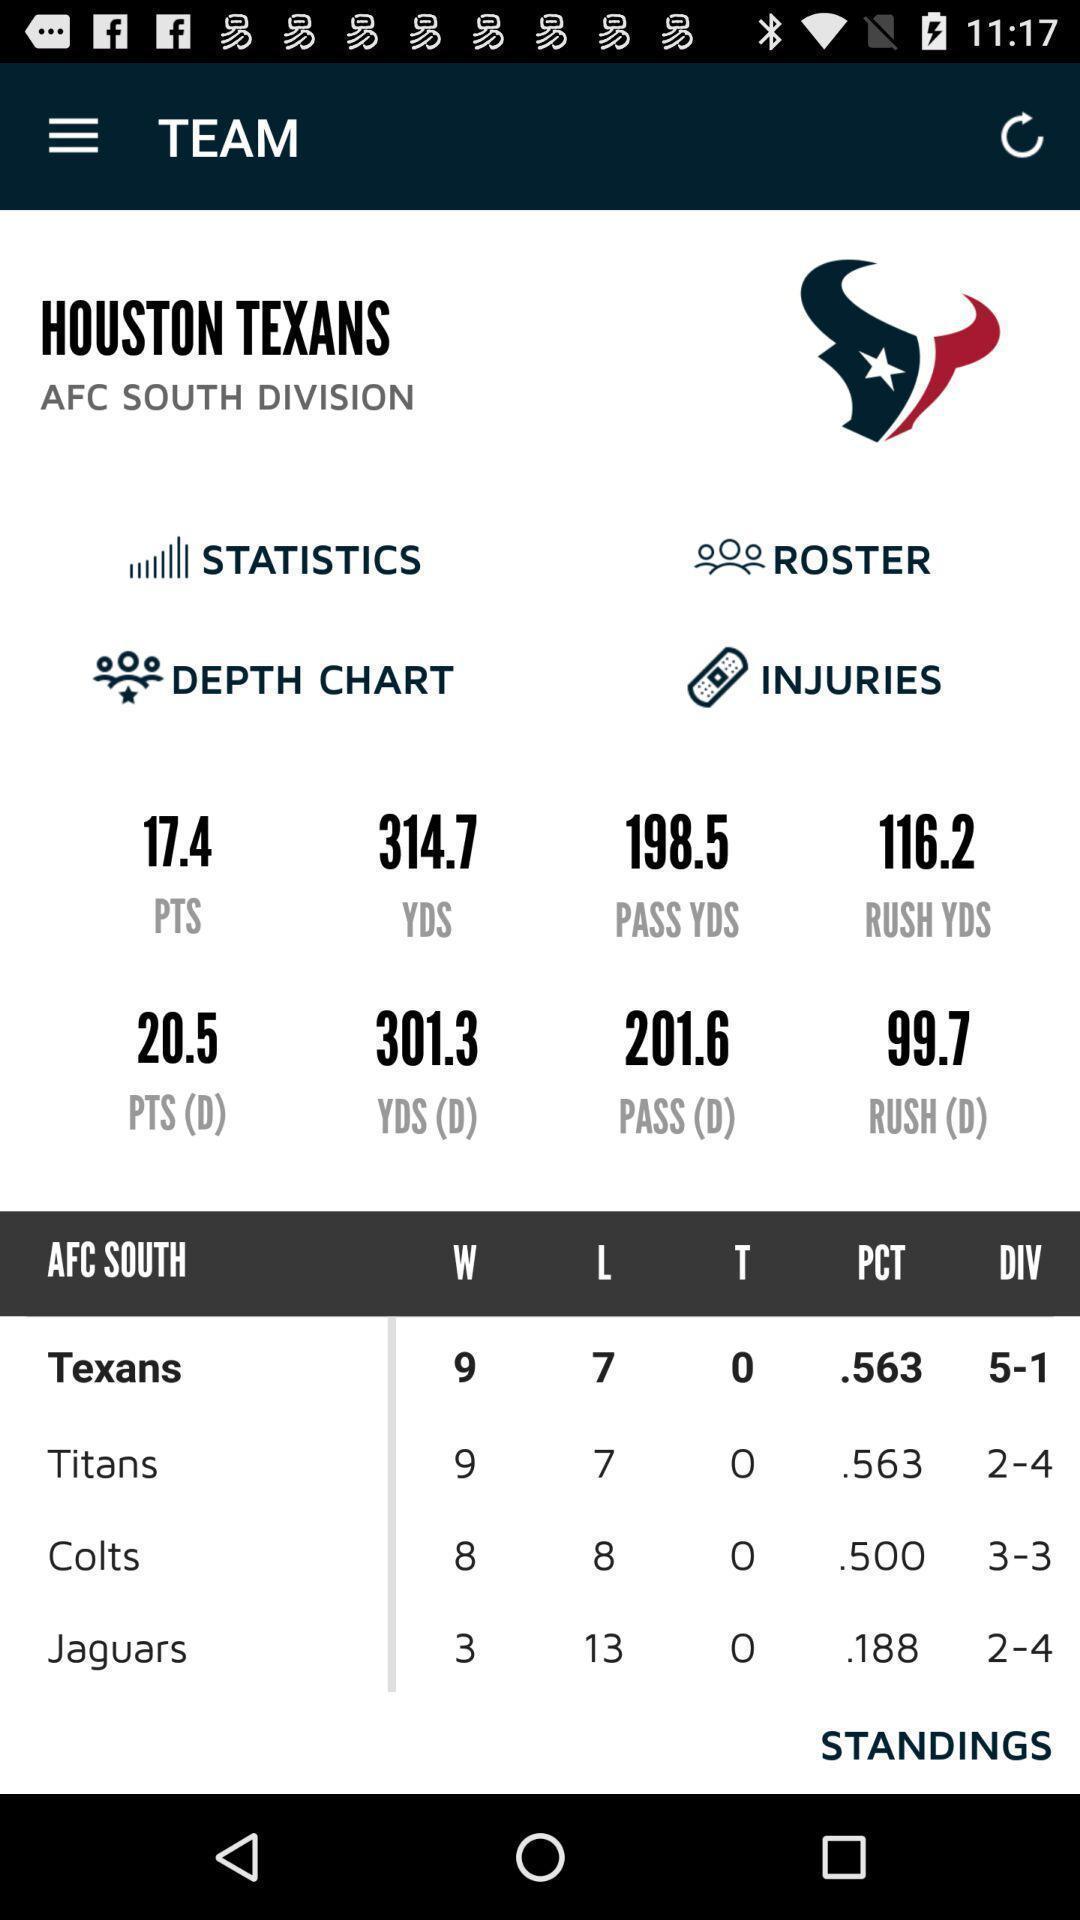Please provide a description for this image. Page showing breaking news about sports. 